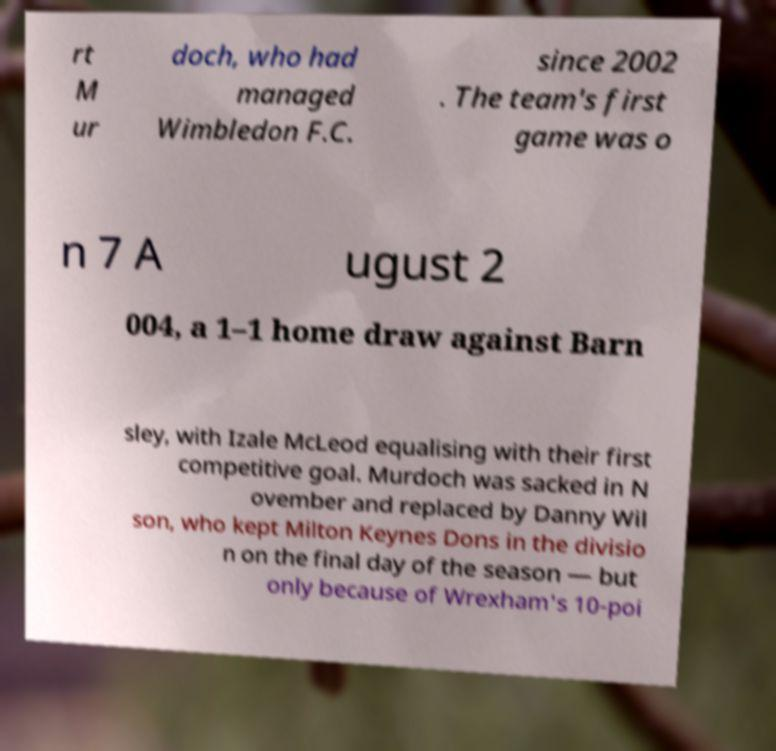Could you extract and type out the text from this image? rt M ur doch, who had managed Wimbledon F.C. since 2002 . The team's first game was o n 7 A ugust 2 004, a 1–1 home draw against Barn sley, with Izale McLeod equalising with their first competitive goal. Murdoch was sacked in N ovember and replaced by Danny Wil son, who kept Milton Keynes Dons in the divisio n on the final day of the season — but only because of Wrexham's 10-poi 